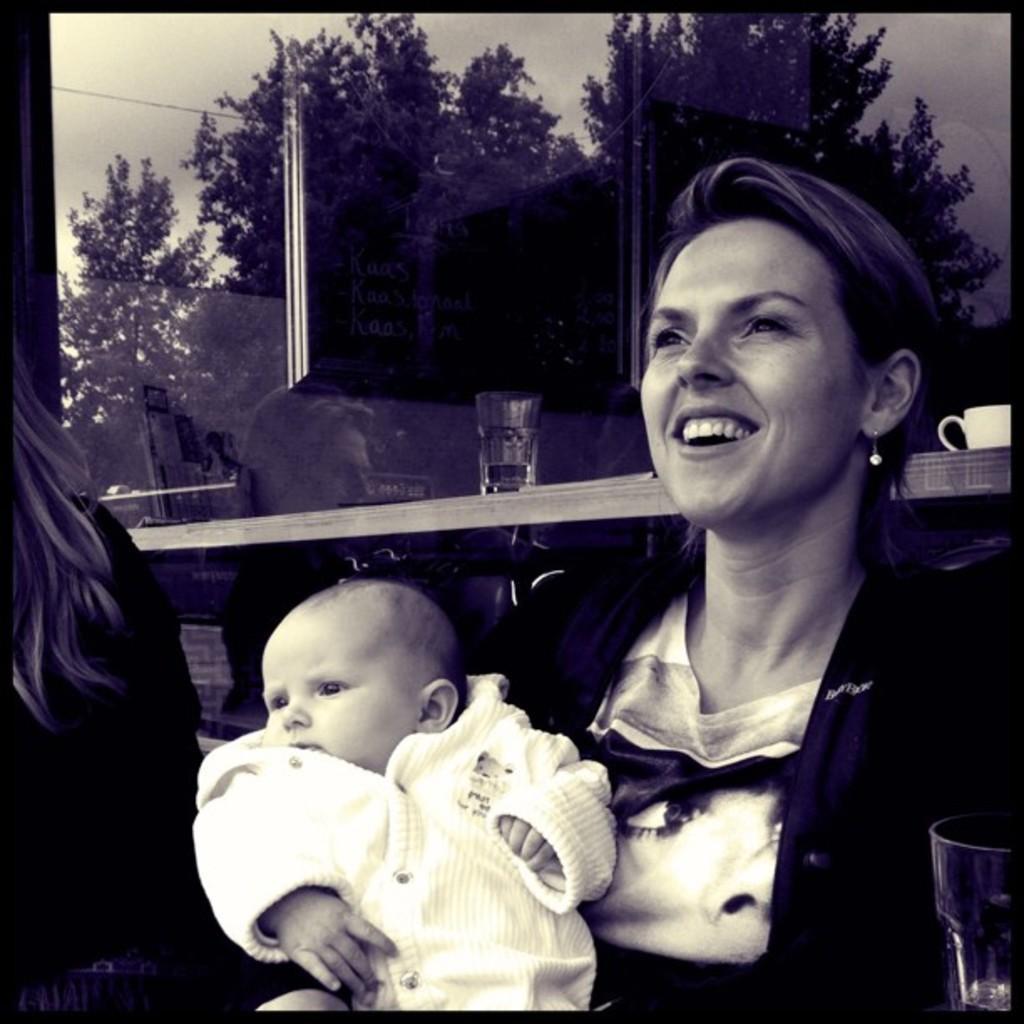Could you give a brief overview of what you see in this image? In this image we can see a woman holding baby in her hands. In the background we can see the reflection of trees, sky, glass tumbler, advertisements, coffee mug and a woman. 